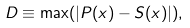<formula> <loc_0><loc_0><loc_500><loc_500>D \equiv \max ( | P ( x ) - S ( x ) | ) ,</formula> 